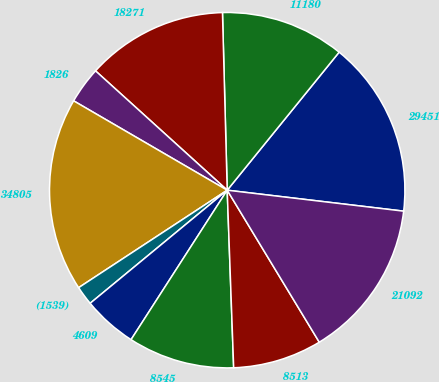Convert chart to OTSL. <chart><loc_0><loc_0><loc_500><loc_500><pie_chart><fcel>29451<fcel>11180<fcel>18271<fcel>1826<fcel>34805<fcel>(1539)<fcel>4609<fcel>8545<fcel>8513<fcel>21092<nl><fcel>16.04%<fcel>11.27%<fcel>12.86%<fcel>3.33%<fcel>17.63%<fcel>1.74%<fcel>4.92%<fcel>9.68%<fcel>8.09%<fcel>14.45%<nl></chart> 